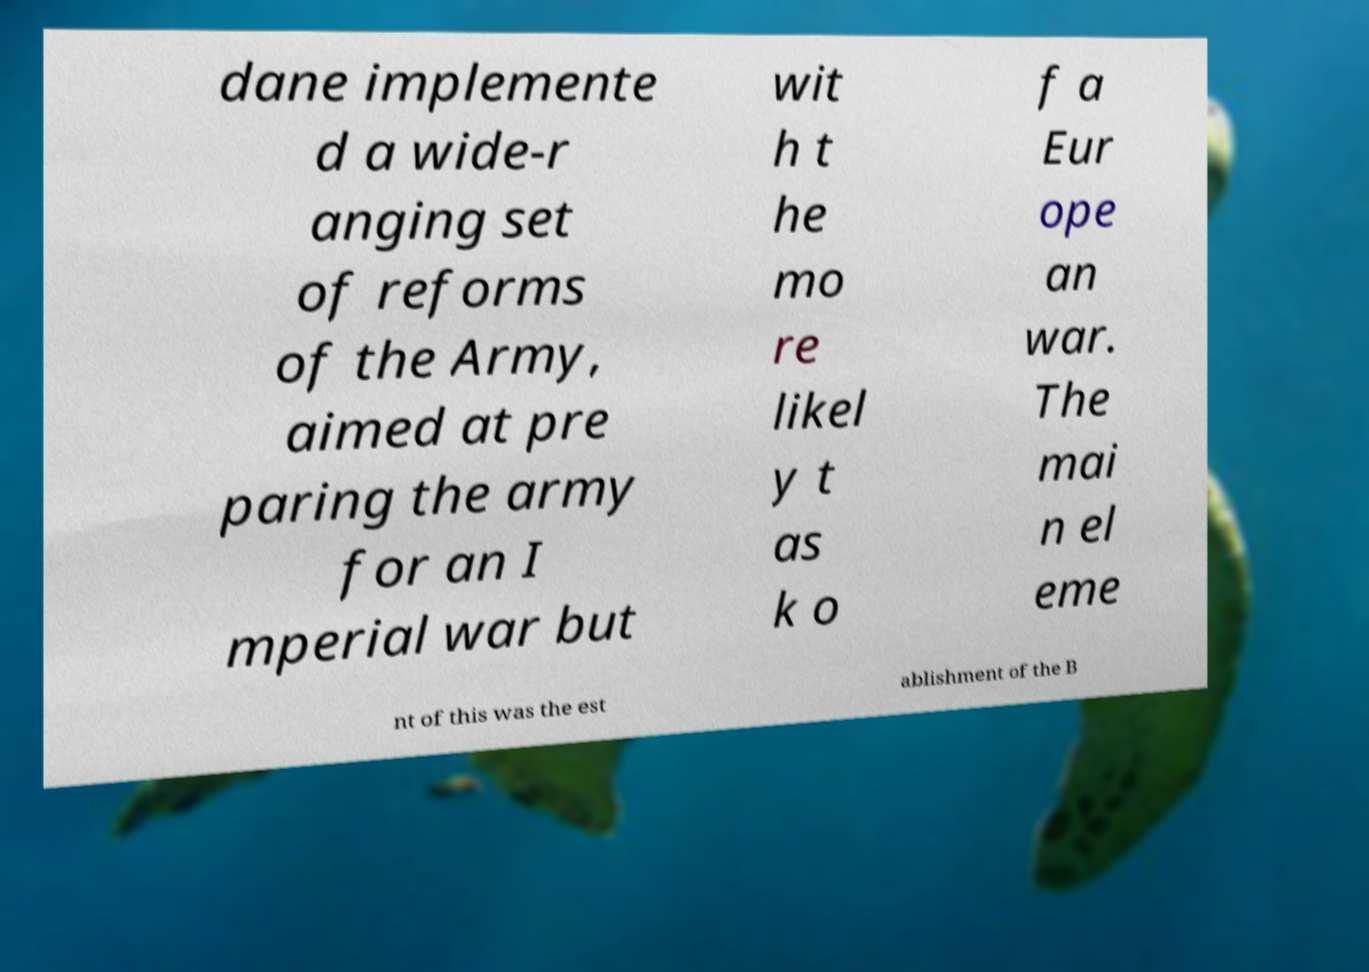Can you accurately transcribe the text from the provided image for me? dane implemente d a wide-r anging set of reforms of the Army, aimed at pre paring the army for an I mperial war but wit h t he mo re likel y t as k o f a Eur ope an war. The mai n el eme nt of this was the est ablishment of the B 